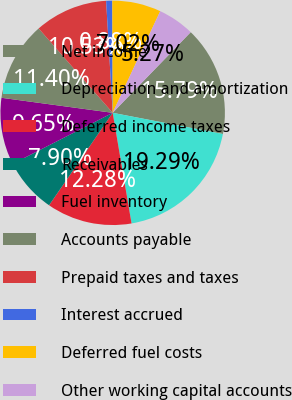<chart> <loc_0><loc_0><loc_500><loc_500><pie_chart><fcel>Net income<fcel>Depreciation and amortization<fcel>Deferred income taxes<fcel>Receivables<fcel>Fuel inventory<fcel>Accounts payable<fcel>Prepaid taxes and taxes<fcel>Interest accrued<fcel>Deferred fuel costs<fcel>Other working capital accounts<nl><fcel>15.79%<fcel>19.29%<fcel>12.28%<fcel>7.9%<fcel>9.65%<fcel>11.4%<fcel>10.53%<fcel>0.88%<fcel>7.02%<fcel>5.27%<nl></chart> 